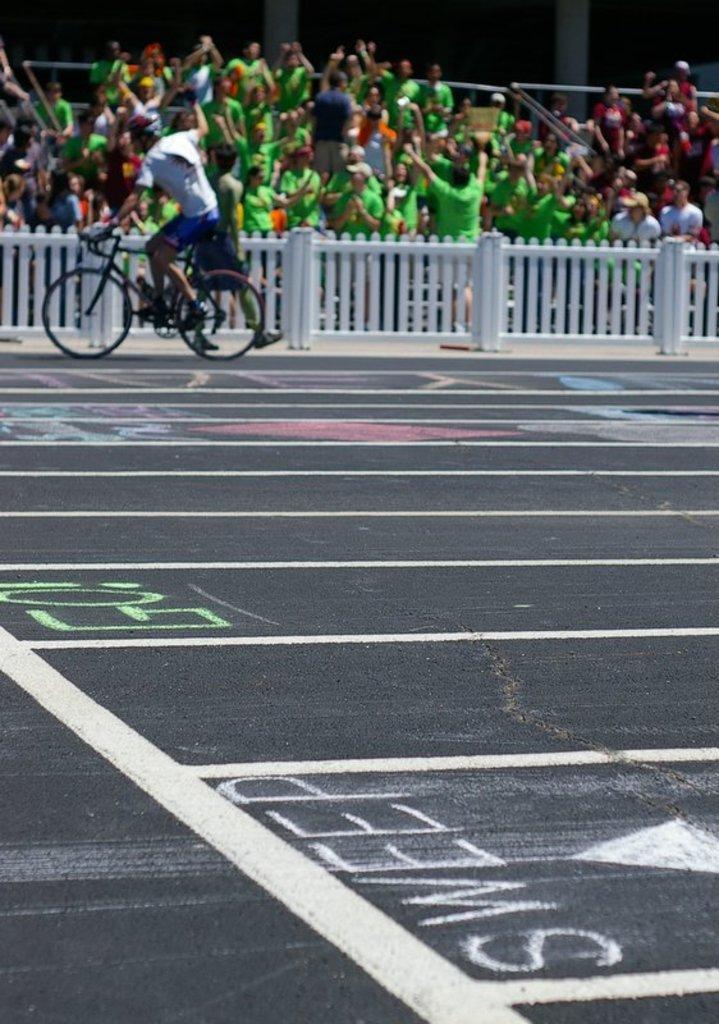Describe this image in one or two sentences. In this picture we can see a man is riding a bicycle on the road and behind the people there is a fence and groups of people. 